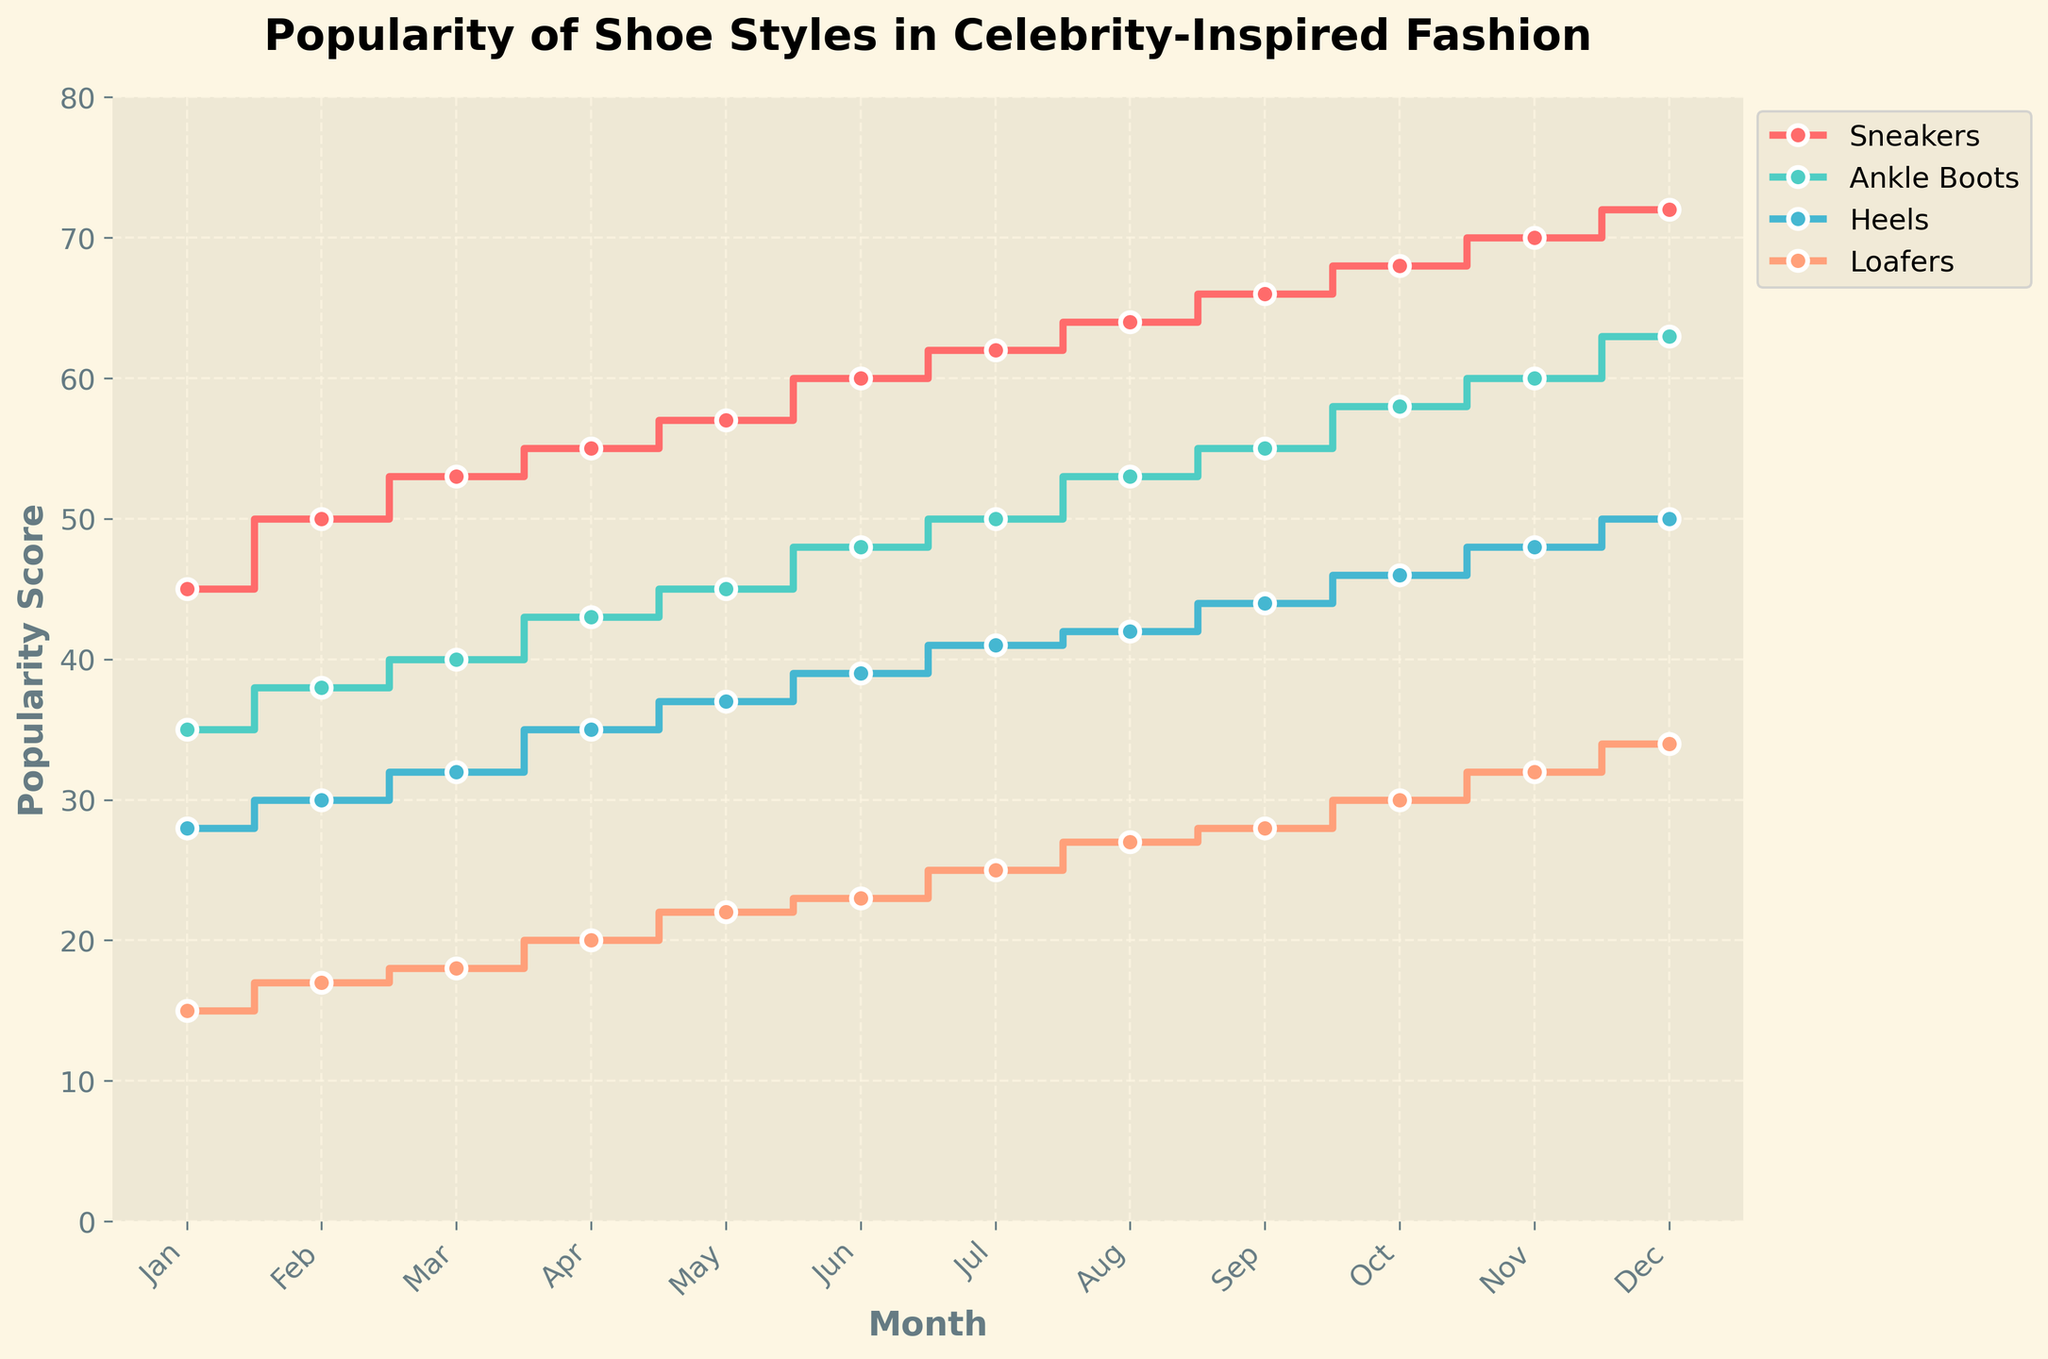How many different shoe styles are displayed in the plot? Count the number of legend labels representing unique shoe styles.
Answer: 4 Which shoe style has the highest popularity score in December? Observe the points at the December mark on the x-axis and compare the popularity scores.
Answer: Sneakers What is the popularity score of loafers in August? Follow the line representing loafers and check the value at August.
Answer: 27 Did the popularity of heels increase or decrease over the year? Compare the popularity scores of heels from January to December.
Answer: Increase Which shoe style showed the greatest overall increase in popularity throughout the year? Calculate the difference between December and January for all styles and compare.
Answer: Sneakers What is the popularity difference between sneakers and ankle boots in November? Subtract the popularity score of ankle boots from that of sneakers in November.
Answer: 10 In which month did loafers have the same popularity score as heels had in April? Identify the popularity score for heels in April and find the corresponding month for loafers.
Answer: September By how much did the popularity score of sneakers increase from the start to the end of the year? Subtract the popularity score of sneakers in January from the score in December.
Answer: 27 Which shoe style has the least popularity in January? Compare all popularity scores for January and identify the lowest score.
Answer: Loafers What's the average popularity score of ankle boots over the year? Add all the monthly popularity scores for ankle boots and divide by 12.
Answer: 48.5 